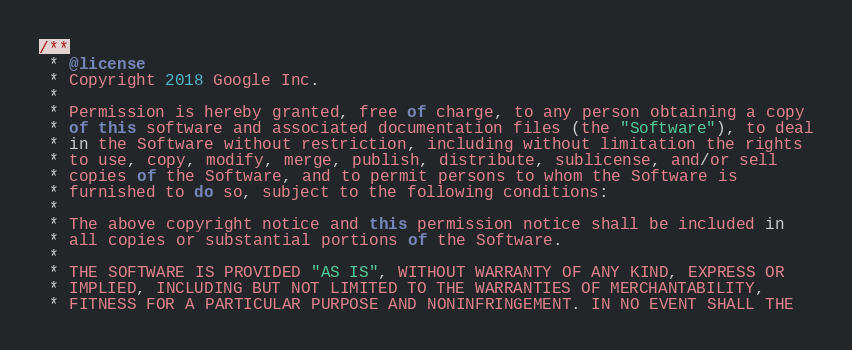Convert code to text. <code><loc_0><loc_0><loc_500><loc_500><_TypeScript_>/**
 * @license
 * Copyright 2018 Google Inc.
 *
 * Permission is hereby granted, free of charge, to any person obtaining a copy
 * of this software and associated documentation files (the "Software"), to deal
 * in the Software without restriction, including without limitation the rights
 * to use, copy, modify, merge, publish, distribute, sublicense, and/or sell
 * copies of the Software, and to permit persons to whom the Software is
 * furnished to do so, subject to the following conditions:
 *
 * The above copyright notice and this permission notice shall be included in
 * all copies or substantial portions of the Software.
 *
 * THE SOFTWARE IS PROVIDED "AS IS", WITHOUT WARRANTY OF ANY KIND, EXPRESS OR
 * IMPLIED, INCLUDING BUT NOT LIMITED TO THE WARRANTIES OF MERCHANTABILITY,
 * FITNESS FOR A PARTICULAR PURPOSE AND NONINFRINGEMENT. IN NO EVENT SHALL THE</code> 